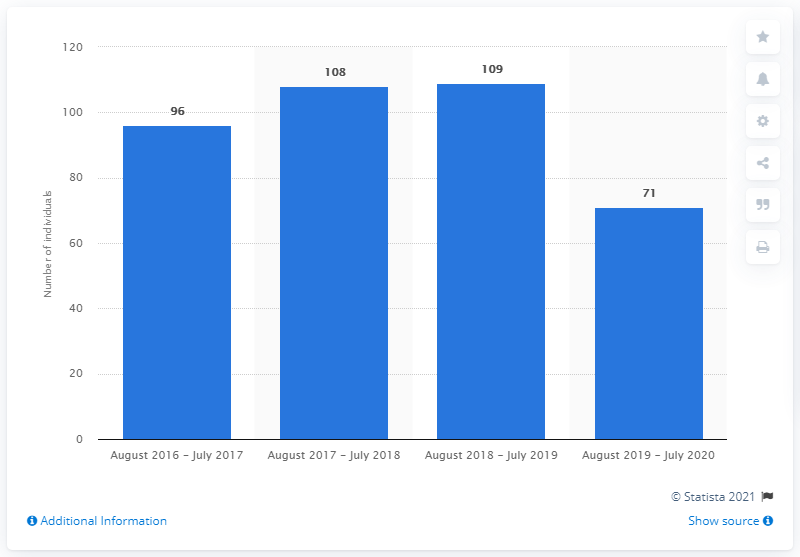Point out several critical features in this image. During the period of August 2019 to July 2020, 71 individuals were forced to leave Italy due to terrorism-related charges. 